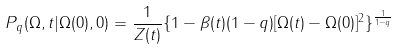Convert formula to latex. <formula><loc_0><loc_0><loc_500><loc_500>P _ { q } ( \Omega , t | \Omega ( 0 ) , 0 ) = \frac { 1 } { Z ( t ) } \{ 1 - \beta ( t ) ( 1 - q ) [ \Omega ( t ) - \Omega ( 0 ) ] ^ { 2 } \} ^ { \frac { 1 } { 1 - q } }</formula> 